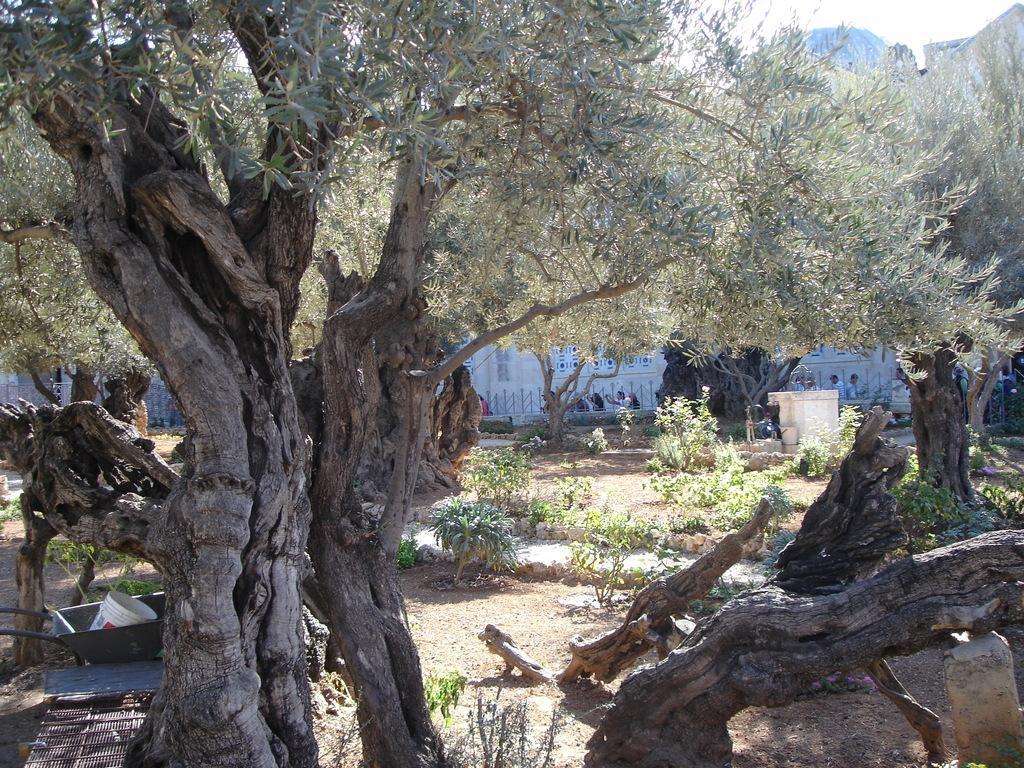How would you summarize this image in a sentence or two? In this image in front there are trees. There are tree barks. On the left side of the image there are a few objects. In the background of the image there are buildings. In front of the buildings there are people. 